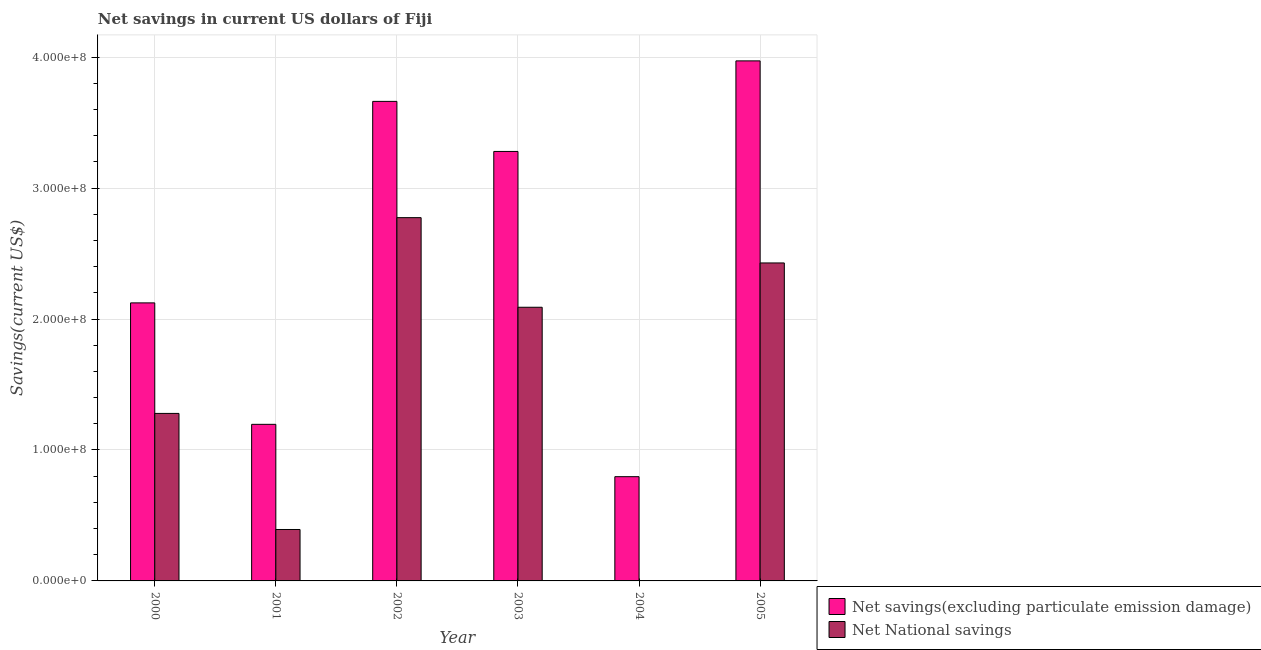How many different coloured bars are there?
Provide a succinct answer. 2. Are the number of bars per tick equal to the number of legend labels?
Your answer should be very brief. No. Are the number of bars on each tick of the X-axis equal?
Your answer should be very brief. No. What is the net national savings in 2003?
Make the answer very short. 2.09e+08. Across all years, what is the maximum net savings(excluding particulate emission damage)?
Ensure brevity in your answer.  3.97e+08. Across all years, what is the minimum net savings(excluding particulate emission damage)?
Make the answer very short. 7.96e+07. What is the total net savings(excluding particulate emission damage) in the graph?
Give a very brief answer. 1.50e+09. What is the difference between the net savings(excluding particulate emission damage) in 2001 and that in 2002?
Your response must be concise. -2.47e+08. What is the difference between the net savings(excluding particulate emission damage) in 2001 and the net national savings in 2000?
Provide a succinct answer. -9.28e+07. What is the average net national savings per year?
Your answer should be very brief. 1.49e+08. In the year 2002, what is the difference between the net national savings and net savings(excluding particulate emission damage)?
Offer a very short reply. 0. What is the ratio of the net savings(excluding particulate emission damage) in 2001 to that in 2004?
Provide a succinct answer. 1.5. Is the net national savings in 2001 less than that in 2005?
Make the answer very short. Yes. Is the difference between the net national savings in 2001 and 2002 greater than the difference between the net savings(excluding particulate emission damage) in 2001 and 2002?
Your answer should be compact. No. What is the difference between the highest and the second highest net national savings?
Ensure brevity in your answer.  3.46e+07. What is the difference between the highest and the lowest net national savings?
Your answer should be very brief. 2.77e+08. Is the sum of the net national savings in 2001 and 2002 greater than the maximum net savings(excluding particulate emission damage) across all years?
Your response must be concise. Yes. How many bars are there?
Your response must be concise. 11. Are all the bars in the graph horizontal?
Your answer should be compact. No. Are the values on the major ticks of Y-axis written in scientific E-notation?
Offer a very short reply. Yes. How many legend labels are there?
Offer a very short reply. 2. What is the title of the graph?
Give a very brief answer. Net savings in current US dollars of Fiji. Does "Taxes on exports" appear as one of the legend labels in the graph?
Make the answer very short. No. What is the label or title of the X-axis?
Ensure brevity in your answer.  Year. What is the label or title of the Y-axis?
Ensure brevity in your answer.  Savings(current US$). What is the Savings(current US$) in Net savings(excluding particulate emission damage) in 2000?
Keep it short and to the point. 2.12e+08. What is the Savings(current US$) of Net National savings in 2000?
Your response must be concise. 1.28e+08. What is the Savings(current US$) in Net savings(excluding particulate emission damage) in 2001?
Give a very brief answer. 1.20e+08. What is the Savings(current US$) in Net National savings in 2001?
Your response must be concise. 3.93e+07. What is the Savings(current US$) of Net savings(excluding particulate emission damage) in 2002?
Offer a very short reply. 3.66e+08. What is the Savings(current US$) in Net National savings in 2002?
Make the answer very short. 2.77e+08. What is the Savings(current US$) of Net savings(excluding particulate emission damage) in 2003?
Offer a terse response. 3.28e+08. What is the Savings(current US$) of Net National savings in 2003?
Ensure brevity in your answer.  2.09e+08. What is the Savings(current US$) of Net savings(excluding particulate emission damage) in 2004?
Your answer should be compact. 7.96e+07. What is the Savings(current US$) of Net National savings in 2004?
Your response must be concise. 0. What is the Savings(current US$) of Net savings(excluding particulate emission damage) in 2005?
Offer a very short reply. 3.97e+08. What is the Savings(current US$) of Net National savings in 2005?
Give a very brief answer. 2.43e+08. Across all years, what is the maximum Savings(current US$) of Net savings(excluding particulate emission damage)?
Your answer should be very brief. 3.97e+08. Across all years, what is the maximum Savings(current US$) in Net National savings?
Keep it short and to the point. 2.77e+08. Across all years, what is the minimum Savings(current US$) in Net savings(excluding particulate emission damage)?
Ensure brevity in your answer.  7.96e+07. What is the total Savings(current US$) of Net savings(excluding particulate emission damage) in the graph?
Make the answer very short. 1.50e+09. What is the total Savings(current US$) in Net National savings in the graph?
Your answer should be very brief. 8.96e+08. What is the difference between the Savings(current US$) in Net savings(excluding particulate emission damage) in 2000 and that in 2001?
Your answer should be compact. 9.28e+07. What is the difference between the Savings(current US$) of Net National savings in 2000 and that in 2001?
Your answer should be compact. 8.87e+07. What is the difference between the Savings(current US$) of Net savings(excluding particulate emission damage) in 2000 and that in 2002?
Give a very brief answer. -1.54e+08. What is the difference between the Savings(current US$) in Net National savings in 2000 and that in 2002?
Your answer should be compact. -1.50e+08. What is the difference between the Savings(current US$) in Net savings(excluding particulate emission damage) in 2000 and that in 2003?
Your response must be concise. -1.16e+08. What is the difference between the Savings(current US$) of Net National savings in 2000 and that in 2003?
Provide a succinct answer. -8.11e+07. What is the difference between the Savings(current US$) of Net savings(excluding particulate emission damage) in 2000 and that in 2004?
Give a very brief answer. 1.33e+08. What is the difference between the Savings(current US$) of Net savings(excluding particulate emission damage) in 2000 and that in 2005?
Offer a terse response. -1.85e+08. What is the difference between the Savings(current US$) of Net National savings in 2000 and that in 2005?
Your answer should be very brief. -1.15e+08. What is the difference between the Savings(current US$) in Net savings(excluding particulate emission damage) in 2001 and that in 2002?
Offer a very short reply. -2.47e+08. What is the difference between the Savings(current US$) in Net National savings in 2001 and that in 2002?
Your response must be concise. -2.38e+08. What is the difference between the Savings(current US$) in Net savings(excluding particulate emission damage) in 2001 and that in 2003?
Give a very brief answer. -2.08e+08. What is the difference between the Savings(current US$) of Net National savings in 2001 and that in 2003?
Provide a short and direct response. -1.70e+08. What is the difference between the Savings(current US$) of Net savings(excluding particulate emission damage) in 2001 and that in 2004?
Provide a succinct answer. 4.00e+07. What is the difference between the Savings(current US$) of Net savings(excluding particulate emission damage) in 2001 and that in 2005?
Ensure brevity in your answer.  -2.78e+08. What is the difference between the Savings(current US$) of Net National savings in 2001 and that in 2005?
Offer a very short reply. -2.04e+08. What is the difference between the Savings(current US$) of Net savings(excluding particulate emission damage) in 2002 and that in 2003?
Ensure brevity in your answer.  3.82e+07. What is the difference between the Savings(current US$) of Net National savings in 2002 and that in 2003?
Provide a succinct answer. 6.84e+07. What is the difference between the Savings(current US$) of Net savings(excluding particulate emission damage) in 2002 and that in 2004?
Give a very brief answer. 2.87e+08. What is the difference between the Savings(current US$) of Net savings(excluding particulate emission damage) in 2002 and that in 2005?
Make the answer very short. -3.09e+07. What is the difference between the Savings(current US$) of Net National savings in 2002 and that in 2005?
Your answer should be very brief. 3.46e+07. What is the difference between the Savings(current US$) in Net savings(excluding particulate emission damage) in 2003 and that in 2004?
Your answer should be compact. 2.48e+08. What is the difference between the Savings(current US$) of Net savings(excluding particulate emission damage) in 2003 and that in 2005?
Your answer should be very brief. -6.92e+07. What is the difference between the Savings(current US$) of Net National savings in 2003 and that in 2005?
Make the answer very short. -3.38e+07. What is the difference between the Savings(current US$) in Net savings(excluding particulate emission damage) in 2004 and that in 2005?
Your answer should be very brief. -3.18e+08. What is the difference between the Savings(current US$) in Net savings(excluding particulate emission damage) in 2000 and the Savings(current US$) in Net National savings in 2001?
Your answer should be compact. 1.73e+08. What is the difference between the Savings(current US$) in Net savings(excluding particulate emission damage) in 2000 and the Savings(current US$) in Net National savings in 2002?
Provide a short and direct response. -6.51e+07. What is the difference between the Savings(current US$) in Net savings(excluding particulate emission damage) in 2000 and the Savings(current US$) in Net National savings in 2003?
Offer a very short reply. 3.35e+06. What is the difference between the Savings(current US$) in Net savings(excluding particulate emission damage) in 2000 and the Savings(current US$) in Net National savings in 2005?
Offer a terse response. -3.05e+07. What is the difference between the Savings(current US$) of Net savings(excluding particulate emission damage) in 2001 and the Savings(current US$) of Net National savings in 2002?
Offer a very short reply. -1.58e+08. What is the difference between the Savings(current US$) of Net savings(excluding particulate emission damage) in 2001 and the Savings(current US$) of Net National savings in 2003?
Provide a short and direct response. -8.94e+07. What is the difference between the Savings(current US$) in Net savings(excluding particulate emission damage) in 2001 and the Savings(current US$) in Net National savings in 2005?
Your answer should be very brief. -1.23e+08. What is the difference between the Savings(current US$) of Net savings(excluding particulate emission damage) in 2002 and the Savings(current US$) of Net National savings in 2003?
Ensure brevity in your answer.  1.57e+08. What is the difference between the Savings(current US$) of Net savings(excluding particulate emission damage) in 2002 and the Savings(current US$) of Net National savings in 2005?
Keep it short and to the point. 1.23e+08. What is the difference between the Savings(current US$) in Net savings(excluding particulate emission damage) in 2003 and the Savings(current US$) in Net National savings in 2005?
Offer a very short reply. 8.52e+07. What is the difference between the Savings(current US$) of Net savings(excluding particulate emission damage) in 2004 and the Savings(current US$) of Net National savings in 2005?
Offer a terse response. -1.63e+08. What is the average Savings(current US$) of Net savings(excluding particulate emission damage) per year?
Make the answer very short. 2.50e+08. What is the average Savings(current US$) of Net National savings per year?
Offer a very short reply. 1.49e+08. In the year 2000, what is the difference between the Savings(current US$) in Net savings(excluding particulate emission damage) and Savings(current US$) in Net National savings?
Your answer should be compact. 8.44e+07. In the year 2001, what is the difference between the Savings(current US$) of Net savings(excluding particulate emission damage) and Savings(current US$) of Net National savings?
Give a very brief answer. 8.03e+07. In the year 2002, what is the difference between the Savings(current US$) of Net savings(excluding particulate emission damage) and Savings(current US$) of Net National savings?
Your answer should be very brief. 8.88e+07. In the year 2003, what is the difference between the Savings(current US$) of Net savings(excluding particulate emission damage) and Savings(current US$) of Net National savings?
Keep it short and to the point. 1.19e+08. In the year 2005, what is the difference between the Savings(current US$) of Net savings(excluding particulate emission damage) and Savings(current US$) of Net National savings?
Offer a terse response. 1.54e+08. What is the ratio of the Savings(current US$) in Net savings(excluding particulate emission damage) in 2000 to that in 2001?
Ensure brevity in your answer.  1.78. What is the ratio of the Savings(current US$) in Net National savings in 2000 to that in 2001?
Give a very brief answer. 3.26. What is the ratio of the Savings(current US$) of Net savings(excluding particulate emission damage) in 2000 to that in 2002?
Keep it short and to the point. 0.58. What is the ratio of the Savings(current US$) in Net National savings in 2000 to that in 2002?
Provide a short and direct response. 0.46. What is the ratio of the Savings(current US$) of Net savings(excluding particulate emission damage) in 2000 to that in 2003?
Your response must be concise. 0.65. What is the ratio of the Savings(current US$) in Net National savings in 2000 to that in 2003?
Your answer should be very brief. 0.61. What is the ratio of the Savings(current US$) of Net savings(excluding particulate emission damage) in 2000 to that in 2004?
Make the answer very short. 2.67. What is the ratio of the Savings(current US$) in Net savings(excluding particulate emission damage) in 2000 to that in 2005?
Offer a terse response. 0.53. What is the ratio of the Savings(current US$) in Net National savings in 2000 to that in 2005?
Keep it short and to the point. 0.53. What is the ratio of the Savings(current US$) in Net savings(excluding particulate emission damage) in 2001 to that in 2002?
Offer a very short reply. 0.33. What is the ratio of the Savings(current US$) of Net National savings in 2001 to that in 2002?
Make the answer very short. 0.14. What is the ratio of the Savings(current US$) of Net savings(excluding particulate emission damage) in 2001 to that in 2003?
Your response must be concise. 0.36. What is the ratio of the Savings(current US$) of Net National savings in 2001 to that in 2003?
Make the answer very short. 0.19. What is the ratio of the Savings(current US$) of Net savings(excluding particulate emission damage) in 2001 to that in 2004?
Keep it short and to the point. 1.5. What is the ratio of the Savings(current US$) in Net savings(excluding particulate emission damage) in 2001 to that in 2005?
Keep it short and to the point. 0.3. What is the ratio of the Savings(current US$) of Net National savings in 2001 to that in 2005?
Offer a very short reply. 0.16. What is the ratio of the Savings(current US$) in Net savings(excluding particulate emission damage) in 2002 to that in 2003?
Offer a terse response. 1.12. What is the ratio of the Savings(current US$) of Net National savings in 2002 to that in 2003?
Offer a very short reply. 1.33. What is the ratio of the Savings(current US$) of Net savings(excluding particulate emission damage) in 2002 to that in 2004?
Ensure brevity in your answer.  4.6. What is the ratio of the Savings(current US$) of Net savings(excluding particulate emission damage) in 2002 to that in 2005?
Your answer should be compact. 0.92. What is the ratio of the Savings(current US$) in Net National savings in 2002 to that in 2005?
Keep it short and to the point. 1.14. What is the ratio of the Savings(current US$) of Net savings(excluding particulate emission damage) in 2003 to that in 2004?
Ensure brevity in your answer.  4.12. What is the ratio of the Savings(current US$) of Net savings(excluding particulate emission damage) in 2003 to that in 2005?
Your response must be concise. 0.83. What is the ratio of the Savings(current US$) in Net National savings in 2003 to that in 2005?
Make the answer very short. 0.86. What is the ratio of the Savings(current US$) of Net savings(excluding particulate emission damage) in 2004 to that in 2005?
Offer a very short reply. 0.2. What is the difference between the highest and the second highest Savings(current US$) in Net savings(excluding particulate emission damage)?
Your response must be concise. 3.09e+07. What is the difference between the highest and the second highest Savings(current US$) in Net National savings?
Offer a very short reply. 3.46e+07. What is the difference between the highest and the lowest Savings(current US$) of Net savings(excluding particulate emission damage)?
Keep it short and to the point. 3.18e+08. What is the difference between the highest and the lowest Savings(current US$) of Net National savings?
Your answer should be very brief. 2.77e+08. 